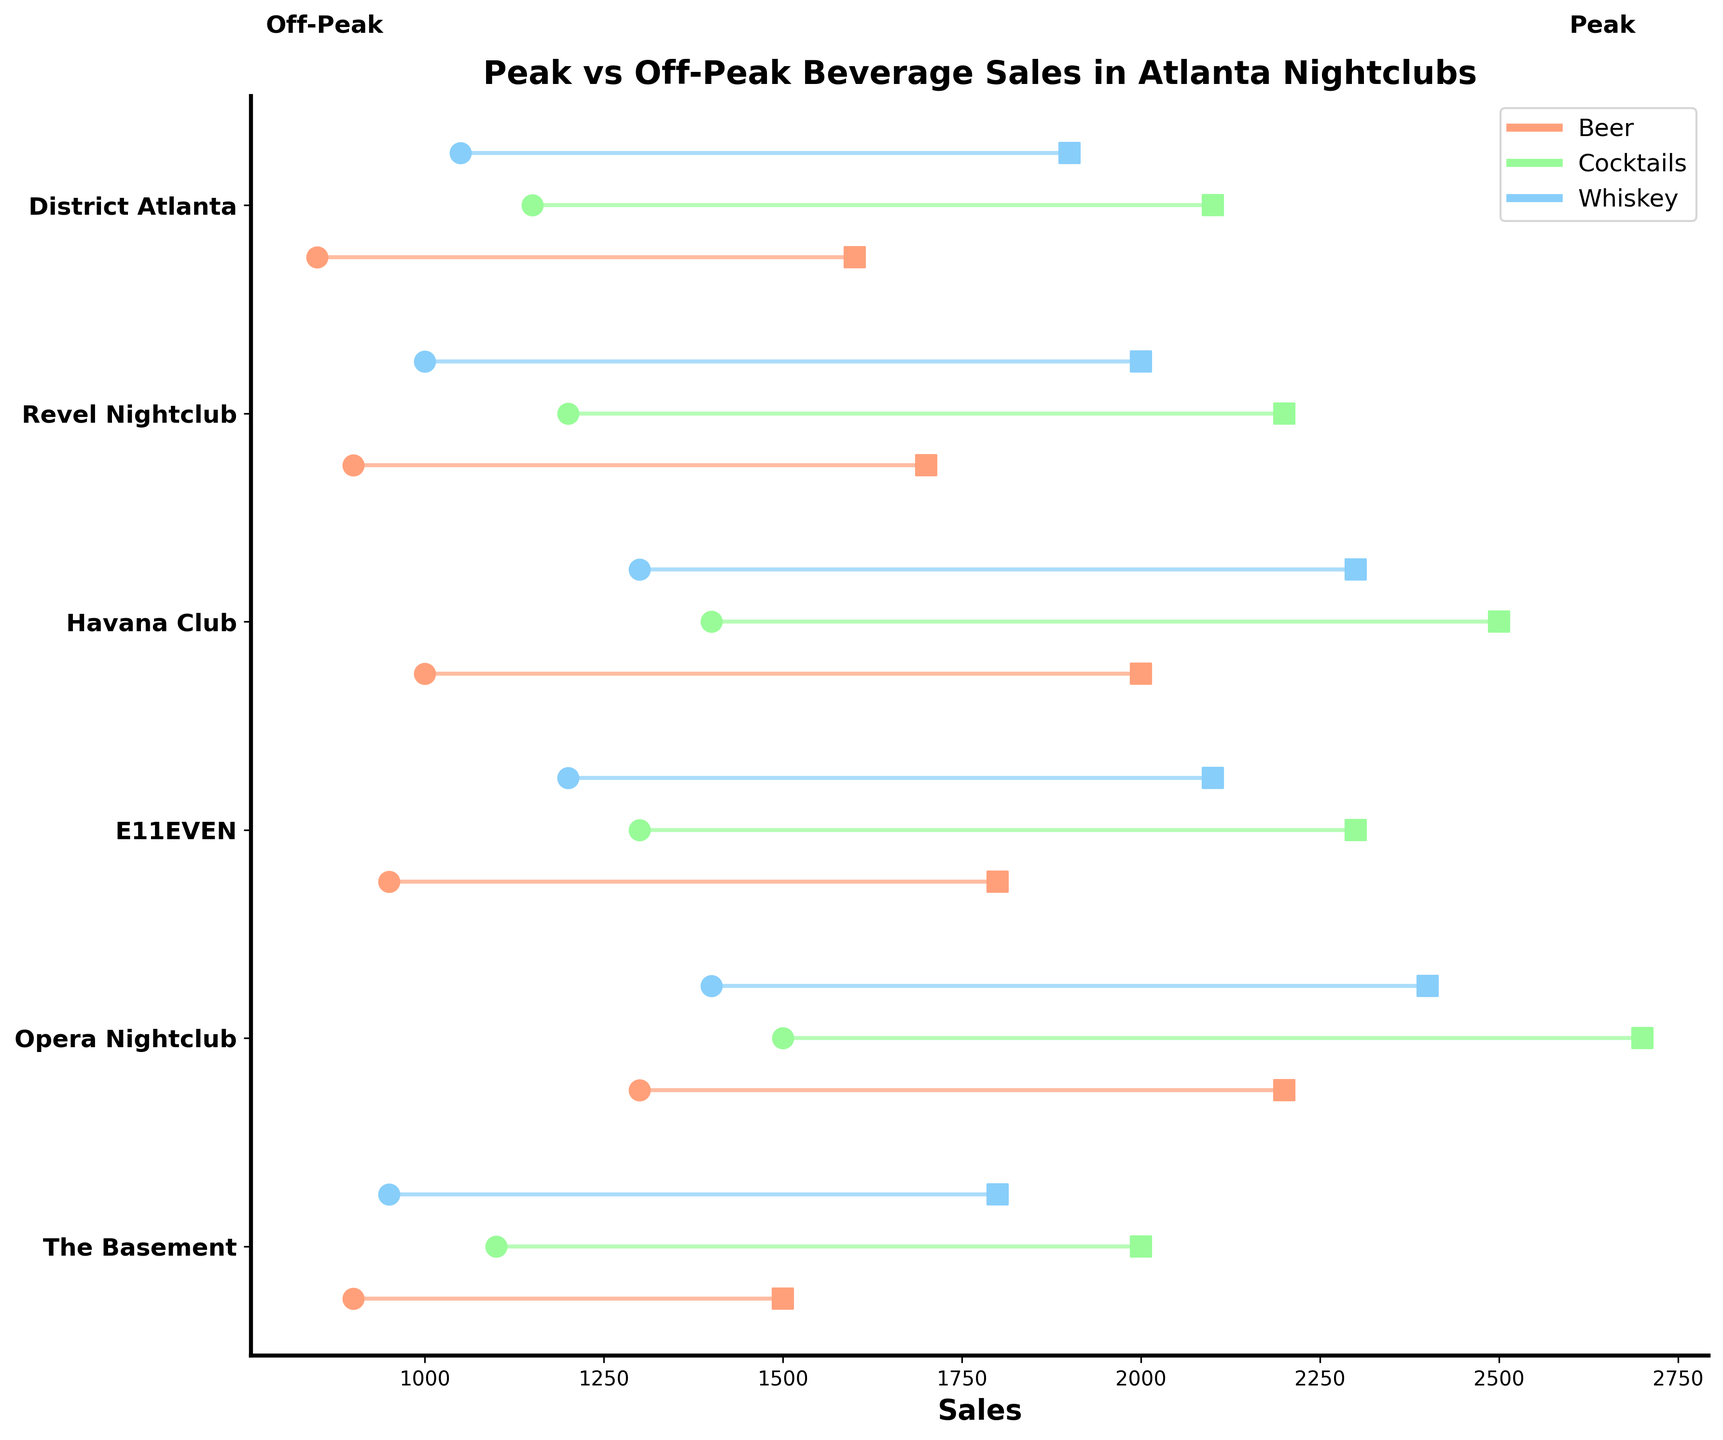What does the plot title say? The plot title is usually found at the top of the plot, which provides an overview of what the plot represents. In this case, it indicates the changes in beverage sales in Atlanta nightclubs during peak vs. off-peak nights.
Answer: Peak vs Off-Peak Beverage Sales in Atlanta Nightclubs Which nightclub has the highest peak sales of whiskey? To determine this, look at the peaks in the sales data for whiskey across all nightclubs. Identify the highest value.
Answer: Opera Nightclub How much higher is peak sales compared to off-peak sales for beer in The Basement? Identify the peak and off-peak sales for beer in The Basement from the plot. Compute the difference between peak and off-peak sales.
Answer: 600 Which beverage shows the smallest difference in sales between peak and off-peak at E11EVEN? Identify peak and off-peak sales for all beverages at E11EVEN. Calculate the differences for each beverage and find the smallest one.
Answer: Beer Which nightclub had the least off-peak sales of cocktails? Look at the off-peak sales for cocktails across all nightclubs in the plot. Identify the lowest value.
Answer: The Basement What is the average peak sales of beer across all nightclubs? Locate the peak sales data for beer for all nightclubs. Sum these values and divide by the number of nightclubs to get the average.
Answer: 1,800 Compare peak sales of cocktails between Havana Club and Revel Nightclub. Which is higher? Identify the peak sales of cocktails for both Havana Club and Revel Nightclub. Compare the two values to see which is higher.
Answer: Havana Club What is the range of sales (difference between peak and off-peak) for whiskey at the Havana Club? Locate the peak and off-peak sales for whiskey at the Havana Club. Subtract the off-peak sales from the peak sales to find the range.
Answer: 1,000 Which beverage appears most frequently across all nightclubs in the figure? Count the occurrence of each beverage type across all nightclubs in the plot. Identify the beverage with the highest count.
Answer: Equal frequency (all the same) What is the total off-peak sales for cocktails across all nightclubs? Locate the off-peak sales for cocktails for all nightclubs. Sum these values to get the total.
Answer: 8,200 